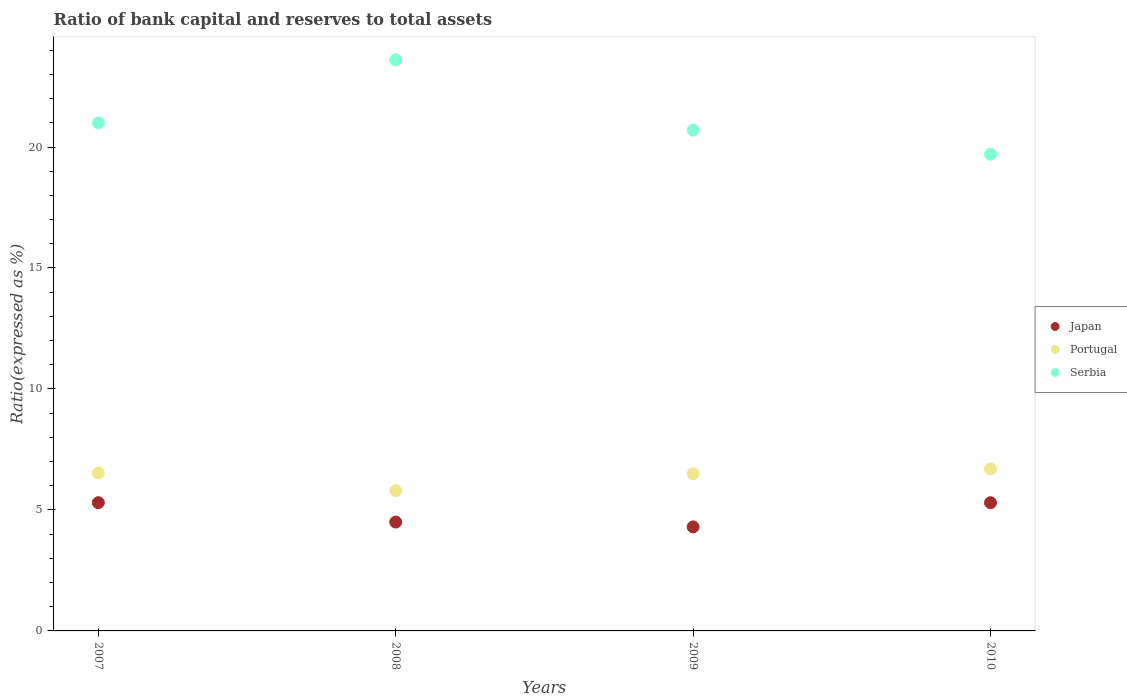How many different coloured dotlines are there?
Your answer should be compact. 3. Is the number of dotlines equal to the number of legend labels?
Ensure brevity in your answer.  Yes. What is the ratio of bank capital and reserves to total assets in Serbia in 2009?
Provide a succinct answer. 20.7. Across all years, what is the maximum ratio of bank capital and reserves to total assets in Serbia?
Your response must be concise. 23.6. Across all years, what is the minimum ratio of bank capital and reserves to total assets in Portugal?
Your answer should be very brief. 5.8. In which year was the ratio of bank capital and reserves to total assets in Japan maximum?
Your answer should be compact. 2007. What is the total ratio of bank capital and reserves to total assets in Japan in the graph?
Provide a succinct answer. 19.4. What is the difference between the ratio of bank capital and reserves to total assets in Portugal in 2009 and that in 2010?
Keep it short and to the point. -0.2. What is the difference between the ratio of bank capital and reserves to total assets in Portugal in 2009 and the ratio of bank capital and reserves to total assets in Japan in 2007?
Your answer should be very brief. 1.19. What is the average ratio of bank capital and reserves to total assets in Serbia per year?
Ensure brevity in your answer.  21.25. In the year 2007, what is the difference between the ratio of bank capital and reserves to total assets in Portugal and ratio of bank capital and reserves to total assets in Japan?
Your answer should be compact. 1.23. What is the ratio of the ratio of bank capital and reserves to total assets in Japan in 2008 to that in 2009?
Keep it short and to the point. 1.05. Is the ratio of bank capital and reserves to total assets in Portugal in 2009 less than that in 2010?
Provide a short and direct response. Yes. What is the difference between the highest and the second highest ratio of bank capital and reserves to total assets in Serbia?
Your response must be concise. 2.6. In how many years, is the ratio of bank capital and reserves to total assets in Japan greater than the average ratio of bank capital and reserves to total assets in Japan taken over all years?
Provide a short and direct response. 2. How many dotlines are there?
Your answer should be very brief. 3. How many years are there in the graph?
Your answer should be very brief. 4. What is the difference between two consecutive major ticks on the Y-axis?
Your answer should be compact. 5. How many legend labels are there?
Make the answer very short. 3. What is the title of the graph?
Provide a short and direct response. Ratio of bank capital and reserves to total assets. What is the label or title of the Y-axis?
Provide a succinct answer. Ratio(expressed as %). What is the Ratio(expressed as %) in Japan in 2007?
Keep it short and to the point. 5.3. What is the Ratio(expressed as %) in Portugal in 2007?
Offer a terse response. 6.53. What is the Ratio(expressed as %) in Serbia in 2007?
Ensure brevity in your answer.  21. What is the Ratio(expressed as %) in Japan in 2008?
Ensure brevity in your answer.  4.5. What is the Ratio(expressed as %) in Portugal in 2008?
Keep it short and to the point. 5.8. What is the Ratio(expressed as %) in Serbia in 2008?
Make the answer very short. 23.6. What is the Ratio(expressed as %) in Japan in 2009?
Provide a succinct answer. 4.3. What is the Ratio(expressed as %) of Portugal in 2009?
Your answer should be compact. 6.49. What is the Ratio(expressed as %) in Serbia in 2009?
Your answer should be compact. 20.7. What is the Ratio(expressed as %) in Portugal in 2010?
Your answer should be compact. 6.7. Across all years, what is the maximum Ratio(expressed as %) of Japan?
Give a very brief answer. 5.3. Across all years, what is the maximum Ratio(expressed as %) in Portugal?
Your answer should be compact. 6.7. Across all years, what is the maximum Ratio(expressed as %) in Serbia?
Make the answer very short. 23.6. Across all years, what is the minimum Ratio(expressed as %) in Portugal?
Make the answer very short. 5.8. Across all years, what is the minimum Ratio(expressed as %) in Serbia?
Ensure brevity in your answer.  19.7. What is the total Ratio(expressed as %) of Portugal in the graph?
Provide a short and direct response. 25.52. What is the total Ratio(expressed as %) in Serbia in the graph?
Your answer should be very brief. 85. What is the difference between the Ratio(expressed as %) in Japan in 2007 and that in 2008?
Your answer should be very brief. 0.8. What is the difference between the Ratio(expressed as %) of Portugal in 2007 and that in 2008?
Ensure brevity in your answer.  0.73. What is the difference between the Ratio(expressed as %) in Serbia in 2007 and that in 2008?
Provide a short and direct response. -2.6. What is the difference between the Ratio(expressed as %) in Portugal in 2007 and that in 2009?
Your answer should be very brief. 0.03. What is the difference between the Ratio(expressed as %) in Serbia in 2007 and that in 2009?
Provide a short and direct response. 0.3. What is the difference between the Ratio(expressed as %) in Japan in 2007 and that in 2010?
Your response must be concise. 0. What is the difference between the Ratio(expressed as %) of Portugal in 2007 and that in 2010?
Ensure brevity in your answer.  -0.17. What is the difference between the Ratio(expressed as %) in Serbia in 2007 and that in 2010?
Provide a short and direct response. 1.3. What is the difference between the Ratio(expressed as %) of Japan in 2008 and that in 2009?
Your answer should be compact. 0.2. What is the difference between the Ratio(expressed as %) in Portugal in 2008 and that in 2009?
Provide a short and direct response. -0.69. What is the difference between the Ratio(expressed as %) in Japan in 2008 and that in 2010?
Your answer should be very brief. -0.8. What is the difference between the Ratio(expressed as %) in Portugal in 2008 and that in 2010?
Offer a terse response. -0.9. What is the difference between the Ratio(expressed as %) in Serbia in 2008 and that in 2010?
Your answer should be compact. 3.9. What is the difference between the Ratio(expressed as %) in Portugal in 2009 and that in 2010?
Offer a very short reply. -0.2. What is the difference between the Ratio(expressed as %) in Japan in 2007 and the Ratio(expressed as %) in Portugal in 2008?
Provide a succinct answer. -0.5. What is the difference between the Ratio(expressed as %) of Japan in 2007 and the Ratio(expressed as %) of Serbia in 2008?
Make the answer very short. -18.3. What is the difference between the Ratio(expressed as %) of Portugal in 2007 and the Ratio(expressed as %) of Serbia in 2008?
Offer a terse response. -17.07. What is the difference between the Ratio(expressed as %) in Japan in 2007 and the Ratio(expressed as %) in Portugal in 2009?
Provide a short and direct response. -1.19. What is the difference between the Ratio(expressed as %) in Japan in 2007 and the Ratio(expressed as %) in Serbia in 2009?
Your response must be concise. -15.4. What is the difference between the Ratio(expressed as %) of Portugal in 2007 and the Ratio(expressed as %) of Serbia in 2009?
Ensure brevity in your answer.  -14.17. What is the difference between the Ratio(expressed as %) of Japan in 2007 and the Ratio(expressed as %) of Portugal in 2010?
Provide a short and direct response. -1.4. What is the difference between the Ratio(expressed as %) of Japan in 2007 and the Ratio(expressed as %) of Serbia in 2010?
Your response must be concise. -14.4. What is the difference between the Ratio(expressed as %) in Portugal in 2007 and the Ratio(expressed as %) in Serbia in 2010?
Your answer should be very brief. -13.17. What is the difference between the Ratio(expressed as %) in Japan in 2008 and the Ratio(expressed as %) in Portugal in 2009?
Give a very brief answer. -1.99. What is the difference between the Ratio(expressed as %) of Japan in 2008 and the Ratio(expressed as %) of Serbia in 2009?
Your answer should be compact. -16.2. What is the difference between the Ratio(expressed as %) in Portugal in 2008 and the Ratio(expressed as %) in Serbia in 2009?
Offer a terse response. -14.9. What is the difference between the Ratio(expressed as %) of Japan in 2008 and the Ratio(expressed as %) of Portugal in 2010?
Ensure brevity in your answer.  -2.2. What is the difference between the Ratio(expressed as %) of Japan in 2008 and the Ratio(expressed as %) of Serbia in 2010?
Your response must be concise. -15.2. What is the difference between the Ratio(expressed as %) of Portugal in 2008 and the Ratio(expressed as %) of Serbia in 2010?
Provide a succinct answer. -13.9. What is the difference between the Ratio(expressed as %) of Japan in 2009 and the Ratio(expressed as %) of Portugal in 2010?
Ensure brevity in your answer.  -2.4. What is the difference between the Ratio(expressed as %) of Japan in 2009 and the Ratio(expressed as %) of Serbia in 2010?
Give a very brief answer. -15.4. What is the difference between the Ratio(expressed as %) in Portugal in 2009 and the Ratio(expressed as %) in Serbia in 2010?
Your response must be concise. -13.21. What is the average Ratio(expressed as %) in Japan per year?
Provide a short and direct response. 4.85. What is the average Ratio(expressed as %) of Portugal per year?
Provide a succinct answer. 6.38. What is the average Ratio(expressed as %) of Serbia per year?
Provide a short and direct response. 21.25. In the year 2007, what is the difference between the Ratio(expressed as %) of Japan and Ratio(expressed as %) of Portugal?
Give a very brief answer. -1.23. In the year 2007, what is the difference between the Ratio(expressed as %) of Japan and Ratio(expressed as %) of Serbia?
Your answer should be very brief. -15.7. In the year 2007, what is the difference between the Ratio(expressed as %) of Portugal and Ratio(expressed as %) of Serbia?
Your response must be concise. -14.47. In the year 2008, what is the difference between the Ratio(expressed as %) in Japan and Ratio(expressed as %) in Portugal?
Give a very brief answer. -1.3. In the year 2008, what is the difference between the Ratio(expressed as %) in Japan and Ratio(expressed as %) in Serbia?
Offer a very short reply. -19.1. In the year 2008, what is the difference between the Ratio(expressed as %) in Portugal and Ratio(expressed as %) in Serbia?
Ensure brevity in your answer.  -17.8. In the year 2009, what is the difference between the Ratio(expressed as %) of Japan and Ratio(expressed as %) of Portugal?
Your answer should be compact. -2.19. In the year 2009, what is the difference between the Ratio(expressed as %) in Japan and Ratio(expressed as %) in Serbia?
Your answer should be compact. -16.4. In the year 2009, what is the difference between the Ratio(expressed as %) in Portugal and Ratio(expressed as %) in Serbia?
Your response must be concise. -14.21. In the year 2010, what is the difference between the Ratio(expressed as %) of Japan and Ratio(expressed as %) of Portugal?
Keep it short and to the point. -1.4. In the year 2010, what is the difference between the Ratio(expressed as %) of Japan and Ratio(expressed as %) of Serbia?
Your answer should be compact. -14.4. In the year 2010, what is the difference between the Ratio(expressed as %) in Portugal and Ratio(expressed as %) in Serbia?
Offer a very short reply. -13. What is the ratio of the Ratio(expressed as %) of Japan in 2007 to that in 2008?
Provide a short and direct response. 1.18. What is the ratio of the Ratio(expressed as %) in Portugal in 2007 to that in 2008?
Your response must be concise. 1.13. What is the ratio of the Ratio(expressed as %) in Serbia in 2007 to that in 2008?
Your response must be concise. 0.89. What is the ratio of the Ratio(expressed as %) in Japan in 2007 to that in 2009?
Make the answer very short. 1.23. What is the ratio of the Ratio(expressed as %) in Serbia in 2007 to that in 2009?
Offer a very short reply. 1.01. What is the ratio of the Ratio(expressed as %) in Portugal in 2007 to that in 2010?
Offer a terse response. 0.97. What is the ratio of the Ratio(expressed as %) in Serbia in 2007 to that in 2010?
Offer a very short reply. 1.07. What is the ratio of the Ratio(expressed as %) of Japan in 2008 to that in 2009?
Make the answer very short. 1.05. What is the ratio of the Ratio(expressed as %) of Portugal in 2008 to that in 2009?
Give a very brief answer. 0.89. What is the ratio of the Ratio(expressed as %) in Serbia in 2008 to that in 2009?
Keep it short and to the point. 1.14. What is the ratio of the Ratio(expressed as %) in Japan in 2008 to that in 2010?
Your answer should be compact. 0.85. What is the ratio of the Ratio(expressed as %) in Portugal in 2008 to that in 2010?
Provide a short and direct response. 0.87. What is the ratio of the Ratio(expressed as %) of Serbia in 2008 to that in 2010?
Provide a succinct answer. 1.2. What is the ratio of the Ratio(expressed as %) of Japan in 2009 to that in 2010?
Your answer should be compact. 0.81. What is the ratio of the Ratio(expressed as %) of Portugal in 2009 to that in 2010?
Provide a short and direct response. 0.97. What is the ratio of the Ratio(expressed as %) of Serbia in 2009 to that in 2010?
Your answer should be compact. 1.05. What is the difference between the highest and the second highest Ratio(expressed as %) of Portugal?
Give a very brief answer. 0.17. What is the difference between the highest and the second highest Ratio(expressed as %) in Serbia?
Keep it short and to the point. 2.6. What is the difference between the highest and the lowest Ratio(expressed as %) of Japan?
Your answer should be very brief. 1. What is the difference between the highest and the lowest Ratio(expressed as %) in Portugal?
Your response must be concise. 0.9. 